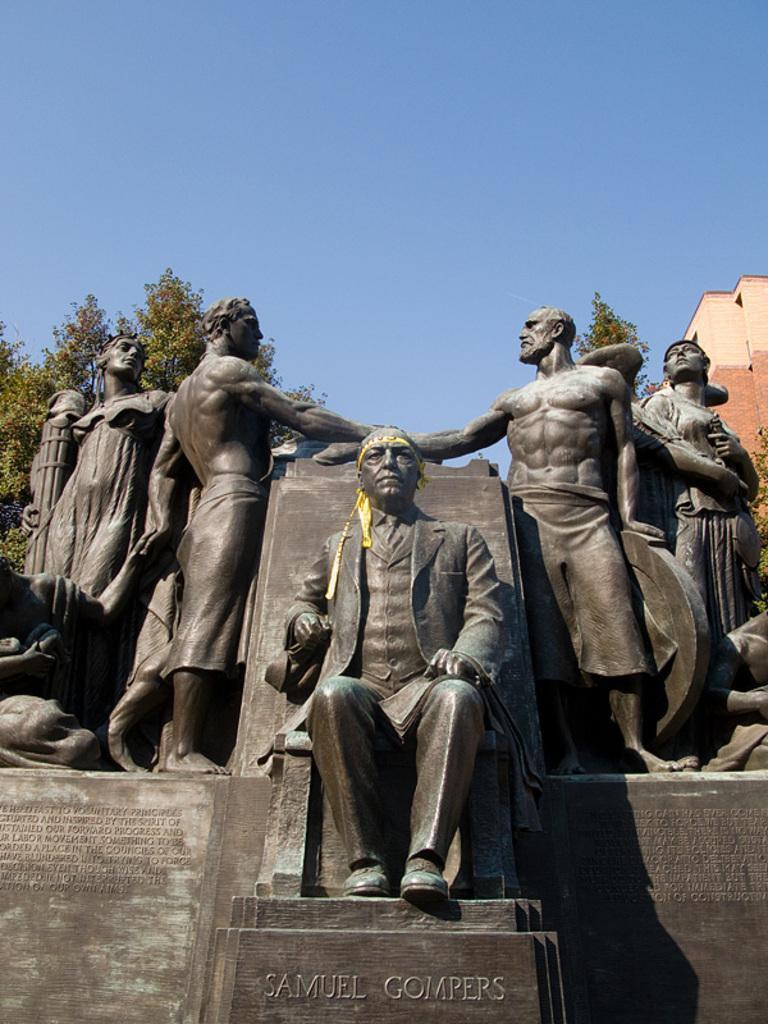Describe this image in one or two sentences. In this image I can see sculptures of five persons and a text. In the background I can see trees, building and the sky. This image is taken may be during a day. 